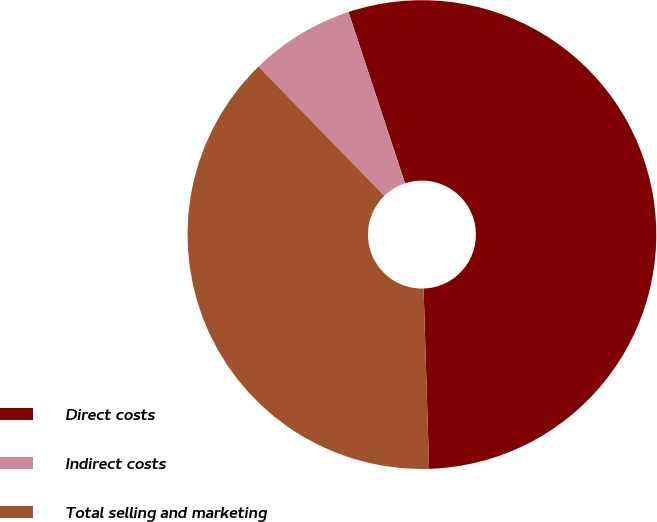Convert chart to OTSL. <chart><loc_0><loc_0><loc_500><loc_500><pie_chart><fcel>Direct costs<fcel>Indirect costs<fcel>Total selling and marketing<nl><fcel>54.59%<fcel>7.21%<fcel>38.21%<nl></chart> 